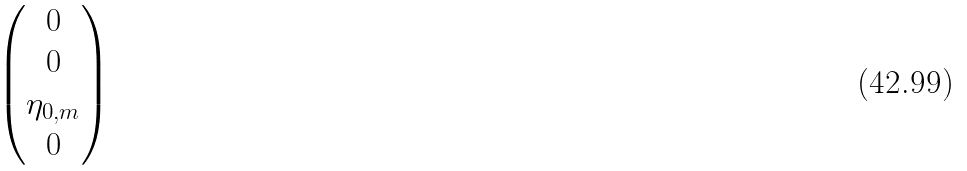Convert formula to latex. <formula><loc_0><loc_0><loc_500><loc_500>\begin{pmatrix} 0 \\ 0 \\ \eta _ { 0 , m } \\ 0 \end{pmatrix}</formula> 